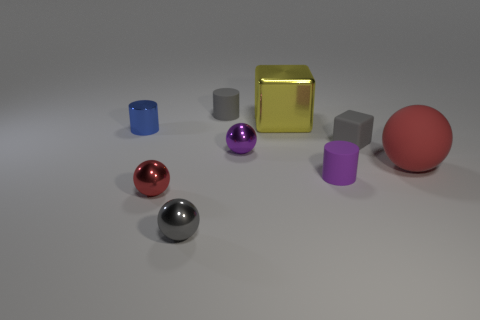What is the shape of the tiny metallic object that is the same color as the big rubber thing?
Provide a short and direct response. Sphere. Are there any large blocks made of the same material as the small blue cylinder?
Provide a succinct answer. Yes. Do the gray thing that is in front of the small purple matte thing and the tiny cylinder that is in front of the tiny blue metal cylinder have the same material?
Provide a short and direct response. No. Are there the same number of purple matte cylinders that are left of the red rubber sphere and tiny purple cylinders on the left side of the big yellow block?
Ensure brevity in your answer.  No. The cube that is the same size as the blue cylinder is what color?
Your answer should be compact. Gray. Is there another sphere of the same color as the large sphere?
Your answer should be compact. Yes. What number of things are tiny metal things in front of the red metal object or shiny cylinders?
Offer a very short reply. 2. How many other objects are there of the same size as the purple ball?
Keep it short and to the point. 6. The tiny purple object that is to the right of the small ball that is behind the red sphere that is right of the tiny gray sphere is made of what material?
Make the answer very short. Rubber. How many cubes are either tiny blue things or big red objects?
Ensure brevity in your answer.  0. 